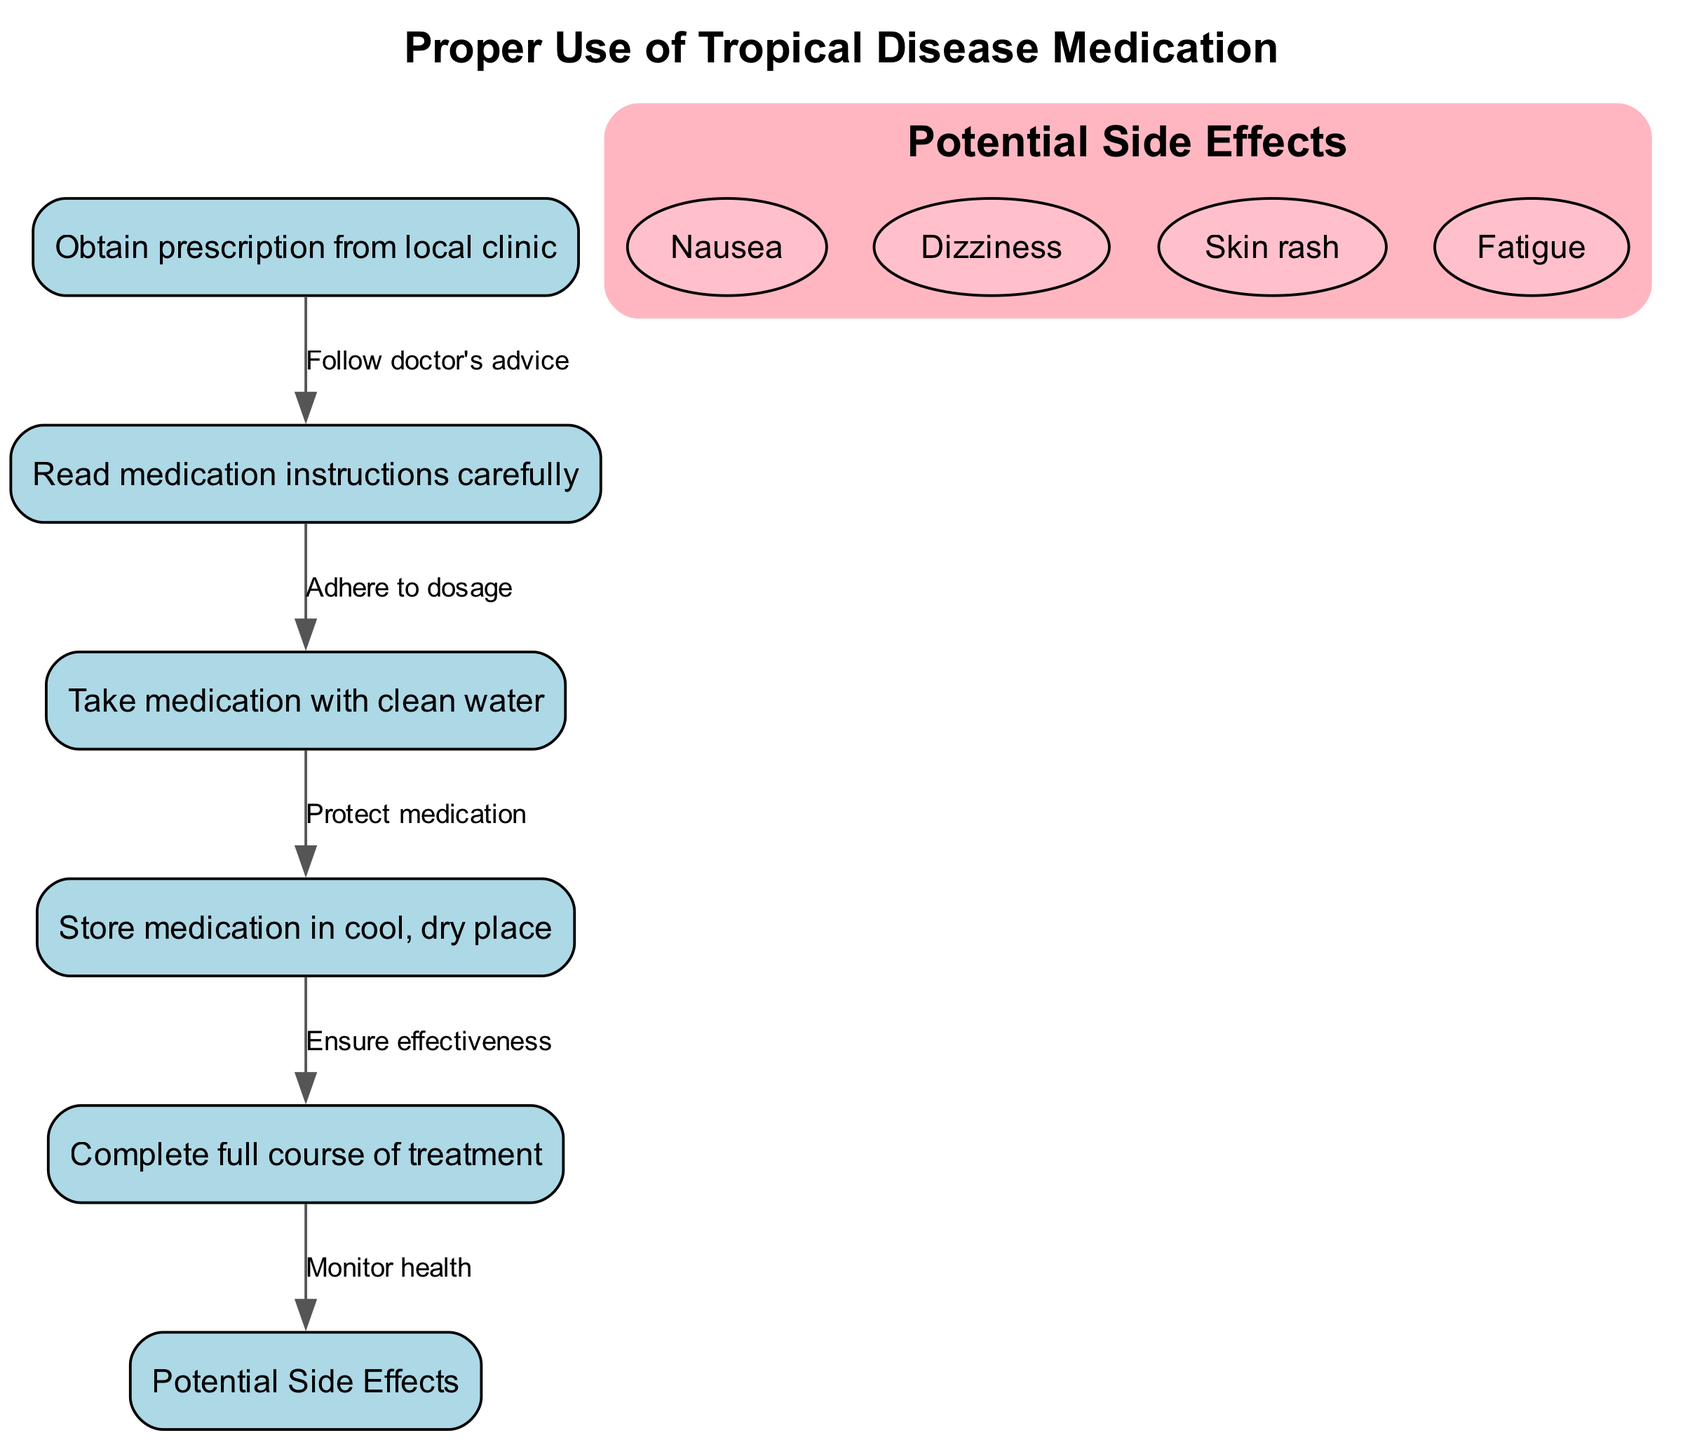What is the first step in using the prescribed medication? The first step as indicated in the diagram is to obtain a prescription from the local clinic, which is labeled as node 1.
Answer: Obtain prescription from local clinic How many potential side effects are listed in the diagram? There are four potential side effects listed in the diagram, which are detailed in the side effects section of node 6.
Answer: 4 What should you do after completing the full course of treatment? After completing the full course of treatment, the next step is to monitor health, as indicated by the directed edge leading from node 5 to node 6.
Answer: Monitor health What action follows reading the medication instructions? After reading the medication instructions carefully, the next action is to take the medication with clean water, as shown by the directed edge from node 2 to node 3.
Answer: Take medication with clean water What is required to ensure the effectiveness of the medication? To ensure effectiveness, the medication must be stored in a cool, dry place, as per the connection between node 4 and node 5.
Answer: Store medication in cool, dry place 